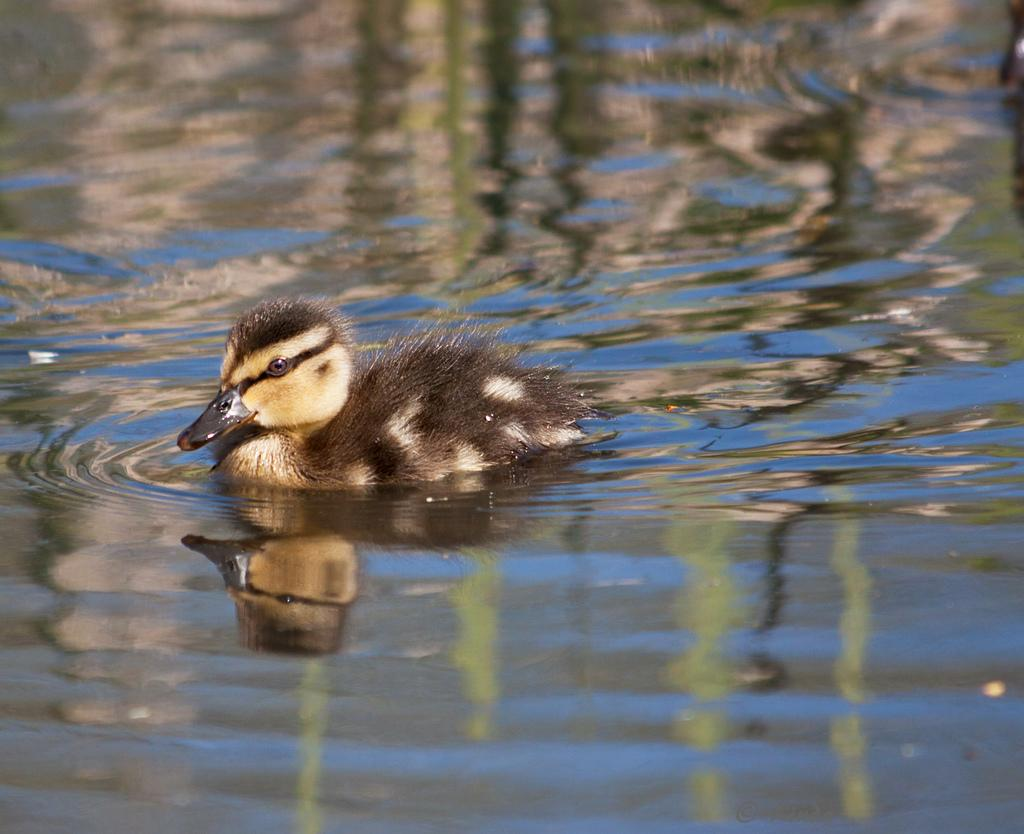What is present in the image that is not solid? There is water visible in the image. What type of animal can be seen in the image? There is a bird in the image. Where can the berry be found in the image? There is no berry present in the image. What type of floor is visible in the image? The image does not show a floor; it only shows water and a bird. 